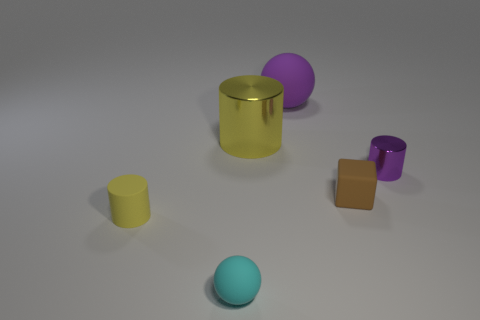Can you guess what material the objects might be made of based on their appearance? While it is difficult to definitively determine material from a still image without texture details, the objects may be made of plastic due to their smooth surfaces and matte appearance, aside from the gold cylinder which could be interpreted as a metallic material given its reflective surface. 